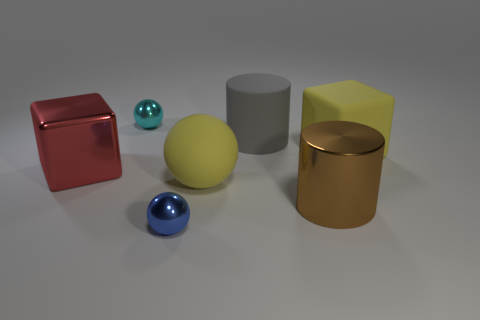Add 2 big yellow rubber things. How many objects exist? 9 Subtract all cylinders. How many objects are left? 5 Add 1 shiny cylinders. How many shiny cylinders exist? 2 Subtract 0 green cubes. How many objects are left? 7 Subtract all large gray rubber objects. Subtract all gray cylinders. How many objects are left? 5 Add 5 blue metallic things. How many blue metallic things are left? 6 